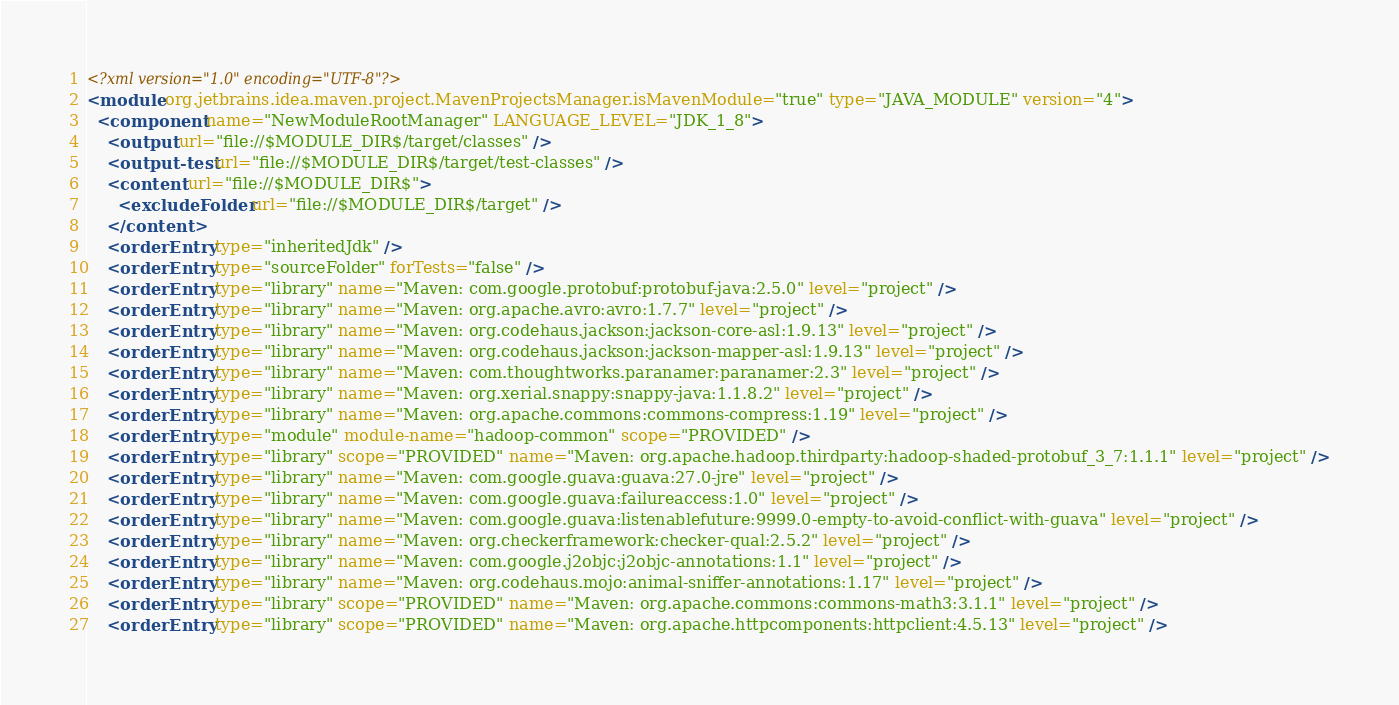<code> <loc_0><loc_0><loc_500><loc_500><_XML_><?xml version="1.0" encoding="UTF-8"?>
<module org.jetbrains.idea.maven.project.MavenProjectsManager.isMavenModule="true" type="JAVA_MODULE" version="4">
  <component name="NewModuleRootManager" LANGUAGE_LEVEL="JDK_1_8">
    <output url="file://$MODULE_DIR$/target/classes" />
    <output-test url="file://$MODULE_DIR$/target/test-classes" />
    <content url="file://$MODULE_DIR$">
      <excludeFolder url="file://$MODULE_DIR$/target" />
    </content>
    <orderEntry type="inheritedJdk" />
    <orderEntry type="sourceFolder" forTests="false" />
    <orderEntry type="library" name="Maven: com.google.protobuf:protobuf-java:2.5.0" level="project" />
    <orderEntry type="library" name="Maven: org.apache.avro:avro:1.7.7" level="project" />
    <orderEntry type="library" name="Maven: org.codehaus.jackson:jackson-core-asl:1.9.13" level="project" />
    <orderEntry type="library" name="Maven: org.codehaus.jackson:jackson-mapper-asl:1.9.13" level="project" />
    <orderEntry type="library" name="Maven: com.thoughtworks.paranamer:paranamer:2.3" level="project" />
    <orderEntry type="library" name="Maven: org.xerial.snappy:snappy-java:1.1.8.2" level="project" />
    <orderEntry type="library" name="Maven: org.apache.commons:commons-compress:1.19" level="project" />
    <orderEntry type="module" module-name="hadoop-common" scope="PROVIDED" />
    <orderEntry type="library" scope="PROVIDED" name="Maven: org.apache.hadoop.thirdparty:hadoop-shaded-protobuf_3_7:1.1.1" level="project" />
    <orderEntry type="library" name="Maven: com.google.guava:guava:27.0-jre" level="project" />
    <orderEntry type="library" name="Maven: com.google.guava:failureaccess:1.0" level="project" />
    <orderEntry type="library" name="Maven: com.google.guava:listenablefuture:9999.0-empty-to-avoid-conflict-with-guava" level="project" />
    <orderEntry type="library" name="Maven: org.checkerframework:checker-qual:2.5.2" level="project" />
    <orderEntry type="library" name="Maven: com.google.j2objc:j2objc-annotations:1.1" level="project" />
    <orderEntry type="library" name="Maven: org.codehaus.mojo:animal-sniffer-annotations:1.17" level="project" />
    <orderEntry type="library" scope="PROVIDED" name="Maven: org.apache.commons:commons-math3:3.1.1" level="project" />
    <orderEntry type="library" scope="PROVIDED" name="Maven: org.apache.httpcomponents:httpclient:4.5.13" level="project" /></code> 